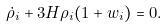<formula> <loc_0><loc_0><loc_500><loc_500>\dot { \rho } _ { i } + 3 H \rho _ { i } ( 1 + w _ { i } ) = 0 .</formula> 